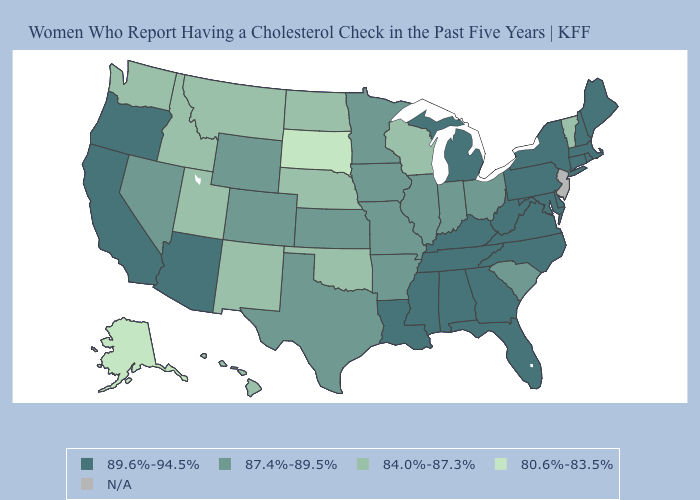Name the states that have a value in the range 89.6%-94.5%?
Quick response, please. Alabama, Arizona, California, Connecticut, Delaware, Florida, Georgia, Kentucky, Louisiana, Maine, Maryland, Massachusetts, Michigan, Mississippi, New Hampshire, New York, North Carolina, Oregon, Pennsylvania, Rhode Island, Tennessee, Virginia, West Virginia. Does Delaware have the highest value in the USA?
Answer briefly. Yes. Among the states that border Washington , does Idaho have the highest value?
Short answer required. No. What is the value of Tennessee?
Short answer required. 89.6%-94.5%. Is the legend a continuous bar?
Keep it brief. No. What is the lowest value in the West?
Short answer required. 80.6%-83.5%. What is the value of Washington?
Concise answer only. 84.0%-87.3%. Name the states that have a value in the range 84.0%-87.3%?
Answer briefly. Hawaii, Idaho, Montana, Nebraska, New Mexico, North Dakota, Oklahoma, Utah, Vermont, Washington, Wisconsin. What is the value of Ohio?
Give a very brief answer. 87.4%-89.5%. What is the highest value in the USA?
Write a very short answer. 89.6%-94.5%. What is the lowest value in the MidWest?
Be succinct. 80.6%-83.5%. Name the states that have a value in the range 84.0%-87.3%?
Quick response, please. Hawaii, Idaho, Montana, Nebraska, New Mexico, North Dakota, Oklahoma, Utah, Vermont, Washington, Wisconsin. What is the highest value in the MidWest ?
Quick response, please. 89.6%-94.5%. Which states have the lowest value in the West?
Concise answer only. Alaska. 